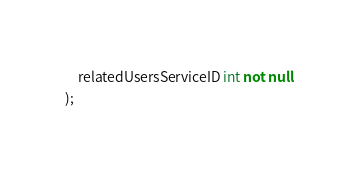Convert code to text. <code><loc_0><loc_0><loc_500><loc_500><_SQL_>    relatedUsersServiceID int not null
);
</code> 